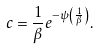Convert formula to latex. <formula><loc_0><loc_0><loc_500><loc_500>c = \frac { 1 } { \beta } e ^ { - \psi \left ( \frac { 1 } { \beta } \right ) } .</formula> 